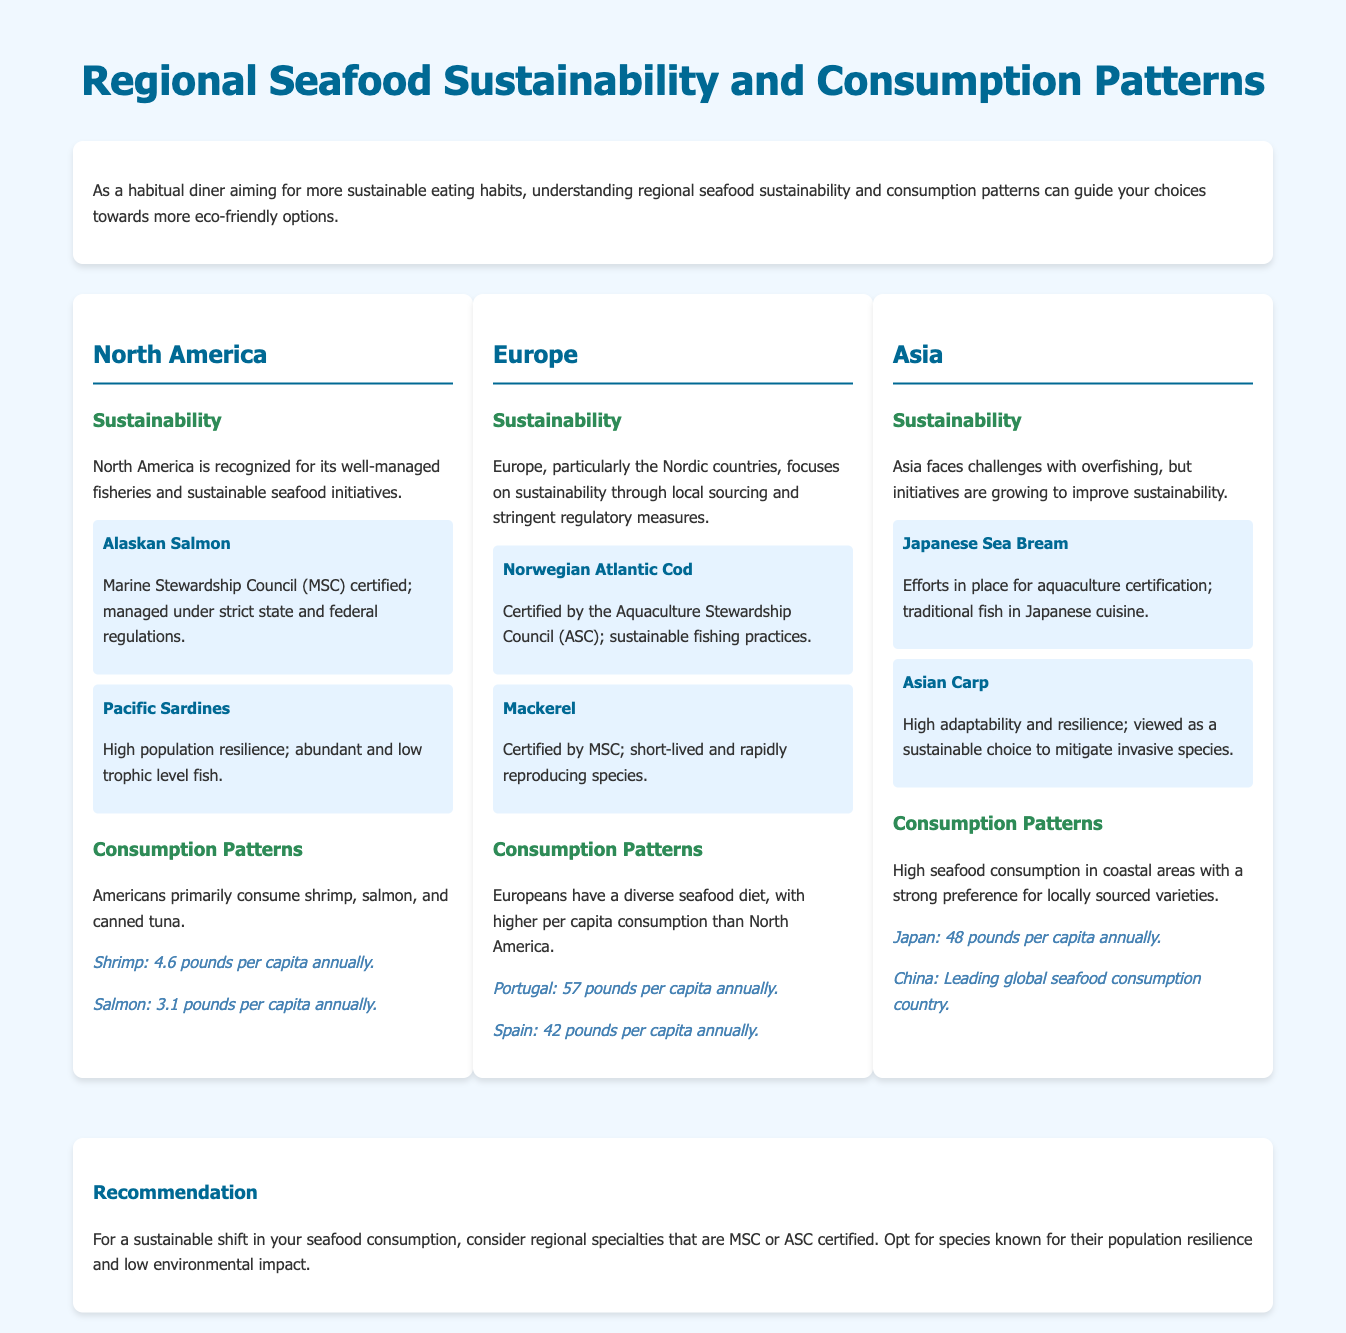What seafood is MSC certified in North America? The document states Alaskan Salmon as an MSC certified seafood in North America.
Answer: Alaskan Salmon What is the per capita shrimp consumption in North America? The shrimp consumption per capita in North America is mentioned as 4.6 pounds annually.
Answer: 4.6 pounds Which country in Europe has the highest per capita seafood consumption? According to the document, Portugal has the highest per capita seafood consumption in Europe at 57 pounds annually.
Answer: Portugal What sustainability certification is mentioned for Norwegian Atlantic Cod? The document specifies that Norwegian Atlantic Cod is certified by the Aquaculture Stewardship Council (ASC).
Answer: ASC Which region faces challenges with overfishing? The document highlights that Asia faces challenges with overfishing.
Answer: Asia What fish is highlighted for its population resilience in North America? The document mentions Pacific Sardines as having high population resilience.
Answer: Pacific Sardines What does the infographic recommend for sustainable seafood choices? The recommendation is to consider regional specialties that are MSC or ASC certified.
Answer: MSC or ASC certified What is the per capita seafood consumption in Japan? The document states that Japan's per capita seafood consumption is 48 pounds annually.
Answer: 48 pounds What seafood has shown adaptive resilience and is viewed as a sustainable choice in Asia? Asian Carp is noted for its high adaptability and resilience.
Answer: Asian Carp 